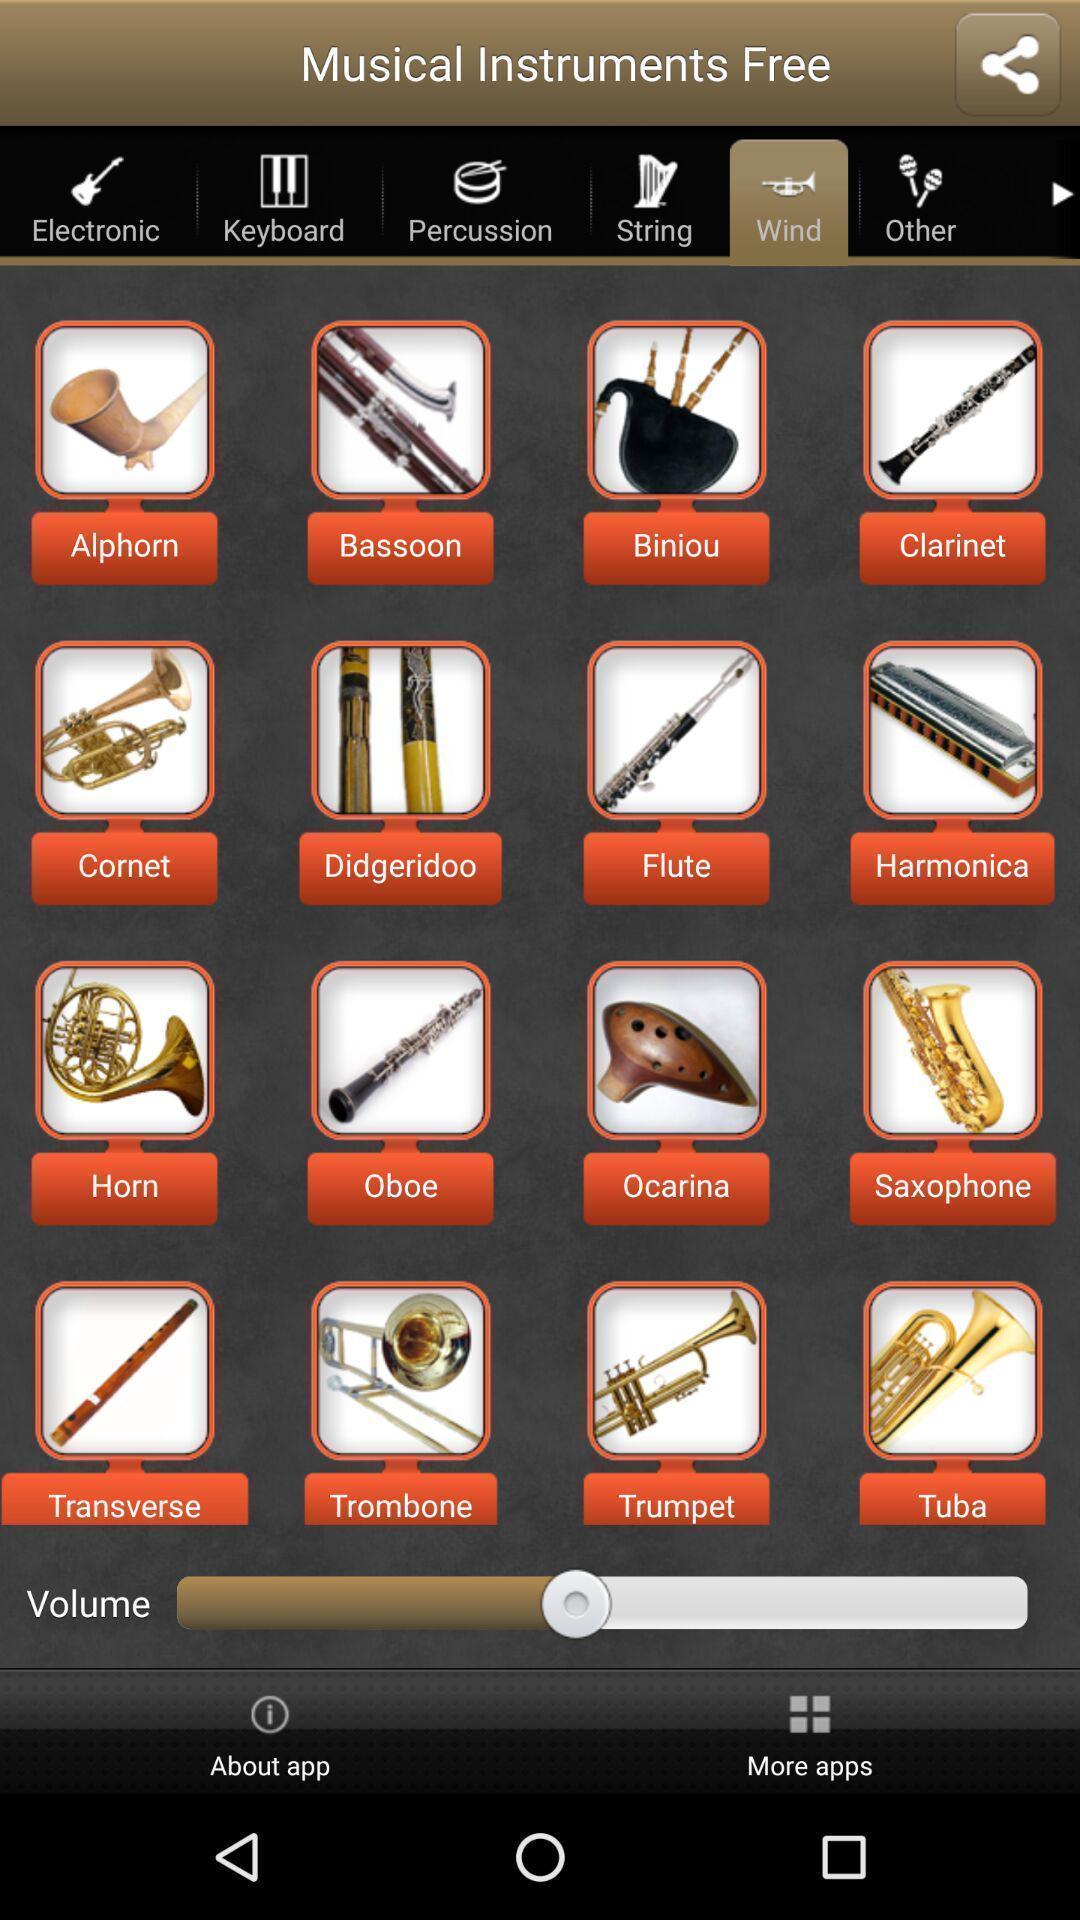Tell me about the visual elements in this screen capture. Screen showing wind instruments. 